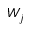<formula> <loc_0><loc_0><loc_500><loc_500>W _ { j }</formula> 